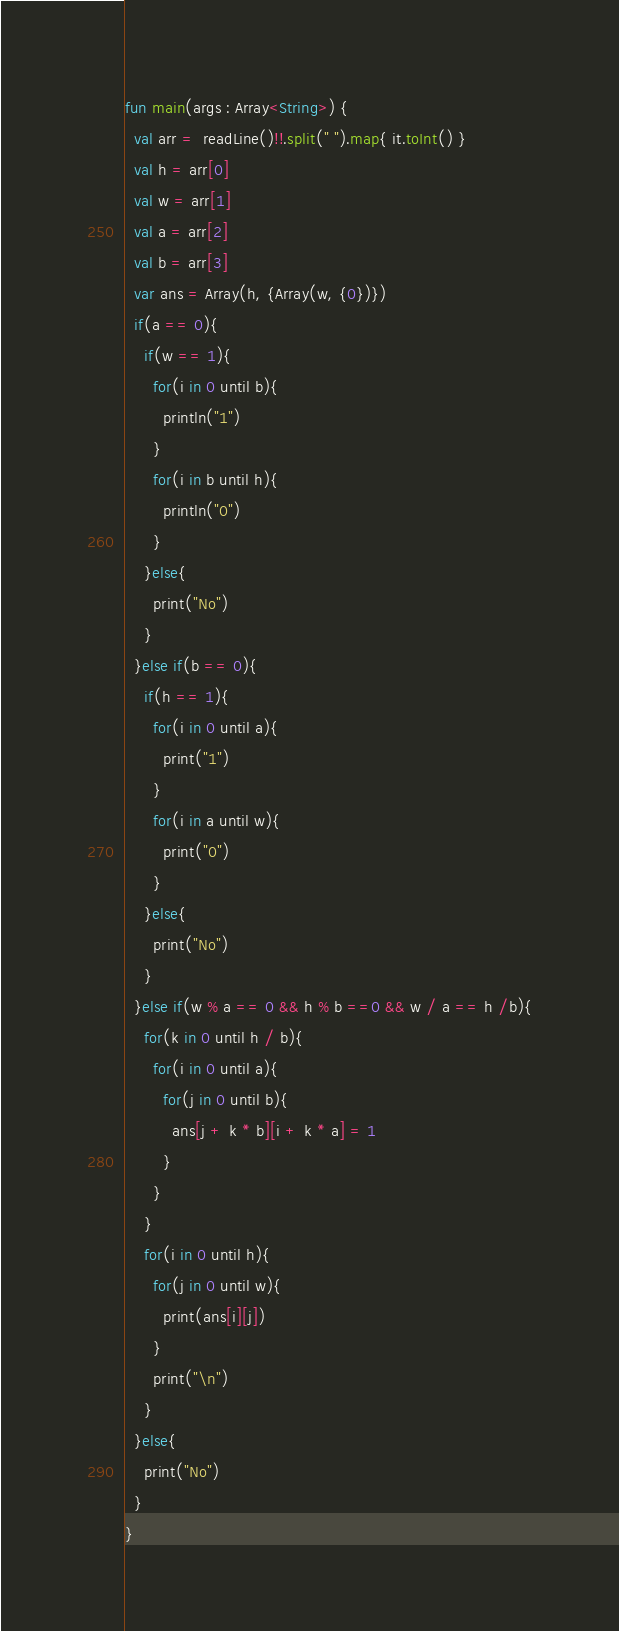<code> <loc_0><loc_0><loc_500><loc_500><_Kotlin_>fun main(args : Array<String>) {
  val arr =  readLine()!!.split(" ").map{ it.toInt() }
  val h = arr[0]
  val w = arr[1]
  val a = arr[2]
  val b = arr[3]
  var ans = Array(h, {Array(w, {0})})
  if(a == 0){
    if(w == 1){
      for(i in 0 until b){
        println("1")
      }
      for(i in b until h){
        println("0")
      }
    }else{
      print("No")
    }
  }else if(b == 0){
    if(h == 1){
      for(i in 0 until a){
        print("1")
      }
      for(i in a until w){
        print("0")
      }
    }else{
      print("No")
    }
  }else if(w % a == 0 && h % b ==0 && w / a == h /b){
    for(k in 0 until h / b){
      for(i in 0 until a){
        for(j in 0 until b){
          ans[j + k * b][i + k * a] = 1
        }
      }
    }
    for(i in 0 until h){
      for(j in 0 until w){
        print(ans[i][j])
      }
      print("\n")
    }
  }else{
    print("No")
  }
}</code> 